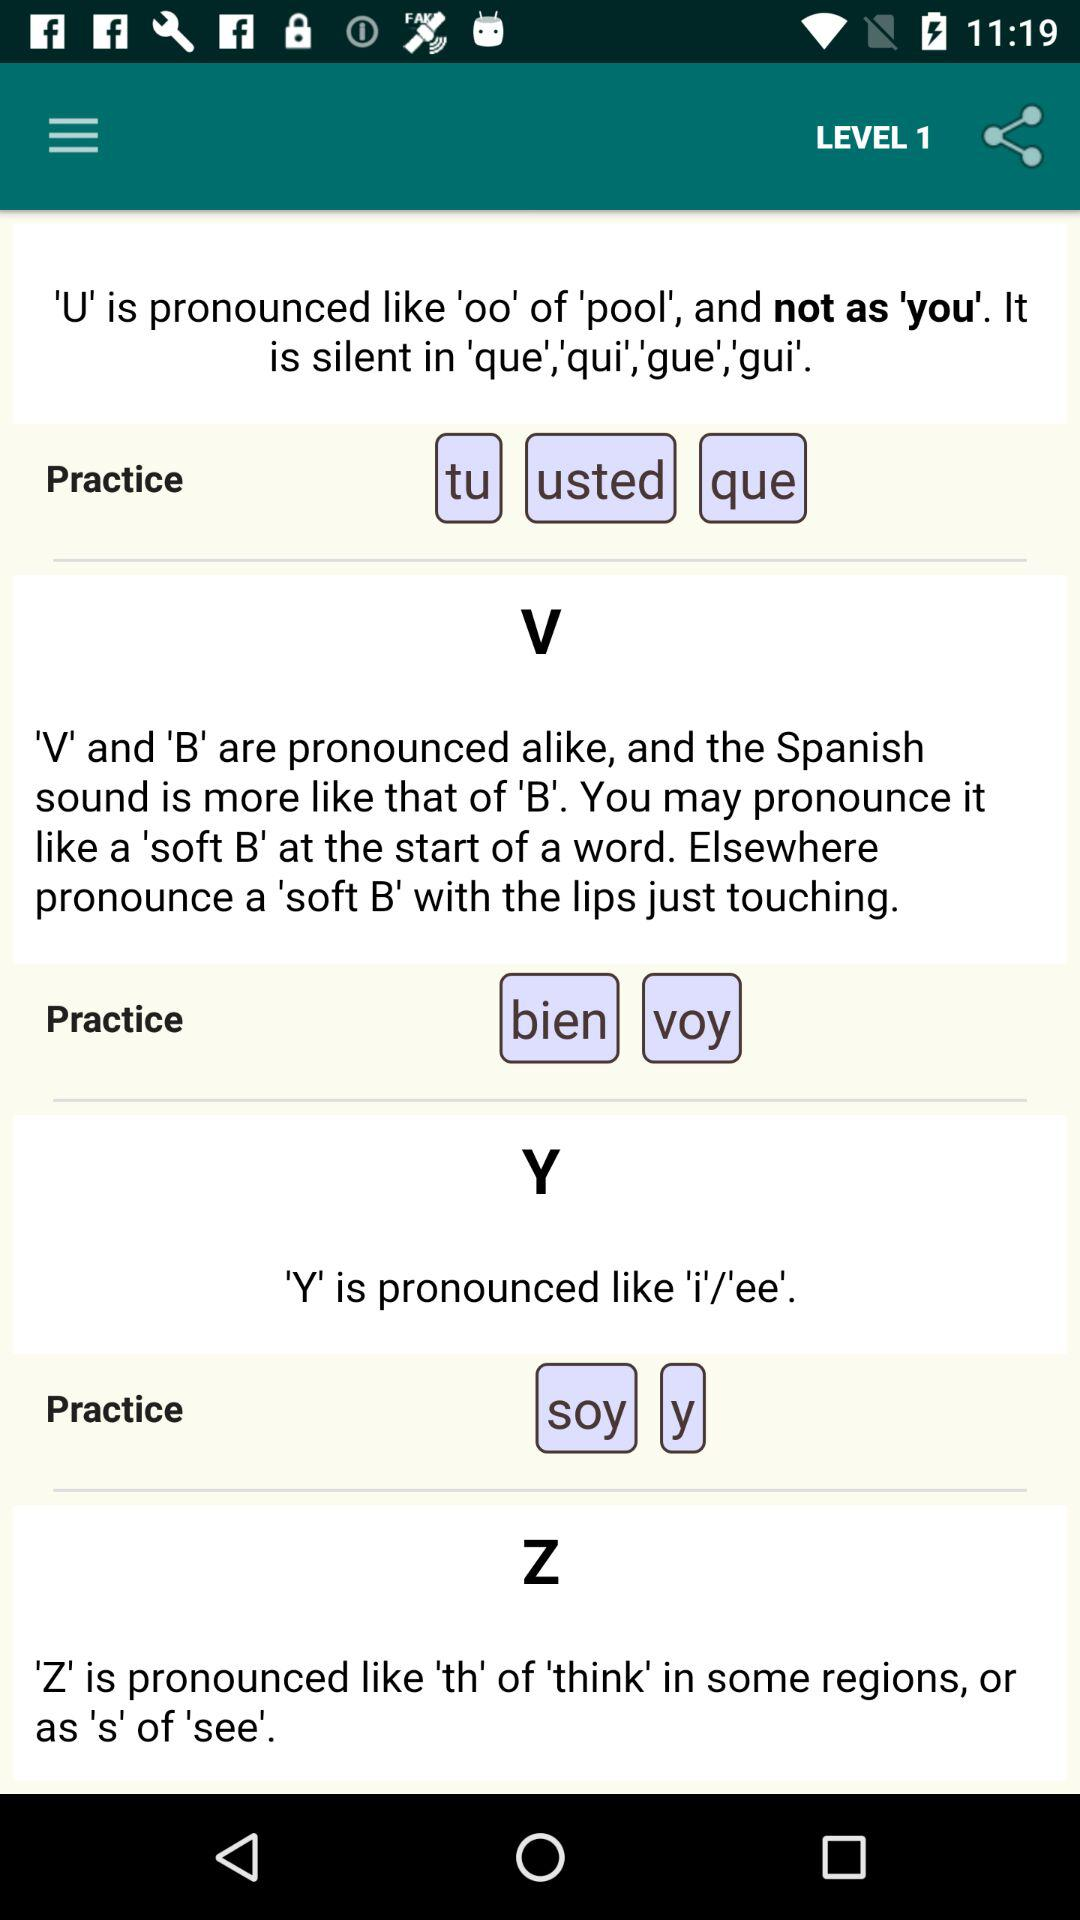Which level are we on? You are on the first level. 